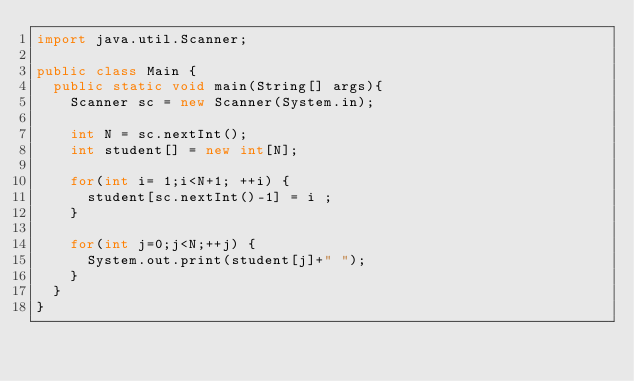<code> <loc_0><loc_0><loc_500><loc_500><_Java_>import java.util.Scanner;

public class Main {
	public static void main(String[] args){
		Scanner sc = new Scanner(System.in);
		
		int N = sc.nextInt();
		int student[] = new int[N];
	
		for(int i= 1;i<N+1; ++i) {
			student[sc.nextInt()-1] = i ;
		}
		
		for(int j=0;j<N;++j) {
			System.out.print(student[j]+" ");
		}
	}	
}</code> 